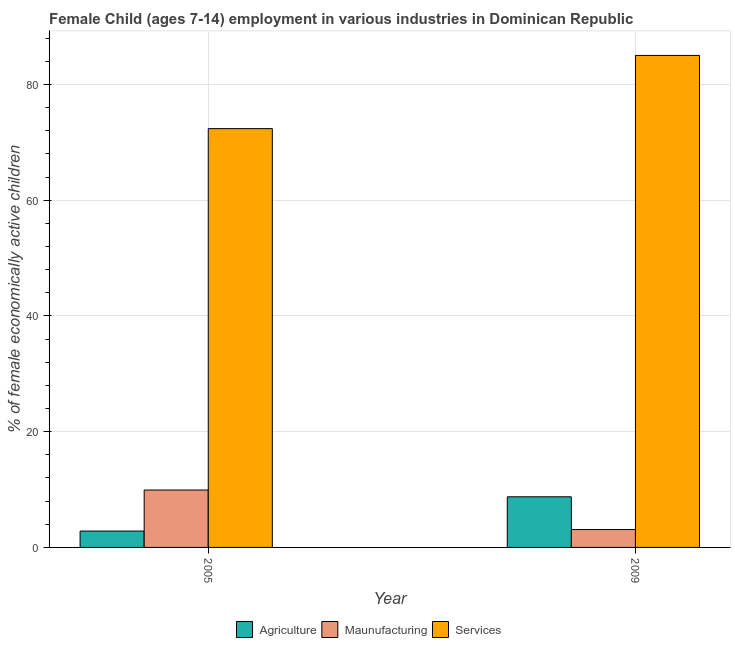How many groups of bars are there?
Your answer should be very brief. 2. Are the number of bars on each tick of the X-axis equal?
Give a very brief answer. Yes. How many bars are there on the 1st tick from the right?
Offer a terse response. 3. What is the percentage of economically active children in services in 2009?
Provide a succinct answer. 85.03. Across all years, what is the maximum percentage of economically active children in services?
Provide a short and direct response. 85.03. Across all years, what is the minimum percentage of economically active children in manufacturing?
Give a very brief answer. 3.09. In which year was the percentage of economically active children in services maximum?
Provide a short and direct response. 2009. What is the total percentage of economically active children in agriculture in the graph?
Provide a succinct answer. 11.58. What is the difference between the percentage of economically active children in services in 2005 and that in 2009?
Provide a short and direct response. -12.65. What is the difference between the percentage of economically active children in manufacturing in 2005 and the percentage of economically active children in agriculture in 2009?
Ensure brevity in your answer.  6.83. What is the average percentage of economically active children in services per year?
Provide a short and direct response. 78.7. In how many years, is the percentage of economically active children in services greater than 20 %?
Your answer should be very brief. 2. What is the ratio of the percentage of economically active children in agriculture in 2005 to that in 2009?
Your response must be concise. 0.32. Is the percentage of economically active children in manufacturing in 2005 less than that in 2009?
Keep it short and to the point. No. In how many years, is the percentage of economically active children in agriculture greater than the average percentage of economically active children in agriculture taken over all years?
Keep it short and to the point. 1. What does the 2nd bar from the left in 2009 represents?
Your answer should be compact. Maunufacturing. What does the 2nd bar from the right in 2009 represents?
Provide a succinct answer. Maunufacturing. Are all the bars in the graph horizontal?
Offer a terse response. No. How many years are there in the graph?
Offer a terse response. 2. Does the graph contain any zero values?
Your answer should be compact. No. Does the graph contain grids?
Offer a terse response. Yes. How many legend labels are there?
Make the answer very short. 3. What is the title of the graph?
Offer a very short reply. Female Child (ages 7-14) employment in various industries in Dominican Republic. Does "Ireland" appear as one of the legend labels in the graph?
Offer a terse response. No. What is the label or title of the X-axis?
Make the answer very short. Year. What is the label or title of the Y-axis?
Your answer should be compact. % of female economically active children. What is the % of female economically active children in Agriculture in 2005?
Give a very brief answer. 2.83. What is the % of female economically active children in Maunufacturing in 2005?
Provide a short and direct response. 9.92. What is the % of female economically active children of Services in 2005?
Keep it short and to the point. 72.38. What is the % of female economically active children in Agriculture in 2009?
Make the answer very short. 8.75. What is the % of female economically active children in Maunufacturing in 2009?
Provide a short and direct response. 3.09. What is the % of female economically active children of Services in 2009?
Provide a succinct answer. 85.03. Across all years, what is the maximum % of female economically active children in Agriculture?
Keep it short and to the point. 8.75. Across all years, what is the maximum % of female economically active children in Maunufacturing?
Your response must be concise. 9.92. Across all years, what is the maximum % of female economically active children in Services?
Your response must be concise. 85.03. Across all years, what is the minimum % of female economically active children in Agriculture?
Keep it short and to the point. 2.83. Across all years, what is the minimum % of female economically active children of Maunufacturing?
Offer a very short reply. 3.09. Across all years, what is the minimum % of female economically active children of Services?
Keep it short and to the point. 72.38. What is the total % of female economically active children of Agriculture in the graph?
Give a very brief answer. 11.58. What is the total % of female economically active children in Maunufacturing in the graph?
Your answer should be very brief. 13.01. What is the total % of female economically active children of Services in the graph?
Keep it short and to the point. 157.41. What is the difference between the % of female economically active children of Agriculture in 2005 and that in 2009?
Keep it short and to the point. -5.92. What is the difference between the % of female economically active children of Maunufacturing in 2005 and that in 2009?
Provide a succinct answer. 6.83. What is the difference between the % of female economically active children of Services in 2005 and that in 2009?
Ensure brevity in your answer.  -12.65. What is the difference between the % of female economically active children of Agriculture in 2005 and the % of female economically active children of Maunufacturing in 2009?
Make the answer very short. -0.26. What is the difference between the % of female economically active children in Agriculture in 2005 and the % of female economically active children in Services in 2009?
Your answer should be very brief. -82.2. What is the difference between the % of female economically active children in Maunufacturing in 2005 and the % of female economically active children in Services in 2009?
Provide a short and direct response. -75.11. What is the average % of female economically active children of Agriculture per year?
Your response must be concise. 5.79. What is the average % of female economically active children of Maunufacturing per year?
Ensure brevity in your answer.  6.5. What is the average % of female economically active children in Services per year?
Provide a short and direct response. 78.7. In the year 2005, what is the difference between the % of female economically active children in Agriculture and % of female economically active children in Maunufacturing?
Ensure brevity in your answer.  -7.09. In the year 2005, what is the difference between the % of female economically active children of Agriculture and % of female economically active children of Services?
Make the answer very short. -69.55. In the year 2005, what is the difference between the % of female economically active children of Maunufacturing and % of female economically active children of Services?
Keep it short and to the point. -62.46. In the year 2009, what is the difference between the % of female economically active children of Agriculture and % of female economically active children of Maunufacturing?
Your response must be concise. 5.66. In the year 2009, what is the difference between the % of female economically active children of Agriculture and % of female economically active children of Services?
Keep it short and to the point. -76.28. In the year 2009, what is the difference between the % of female economically active children in Maunufacturing and % of female economically active children in Services?
Provide a short and direct response. -81.94. What is the ratio of the % of female economically active children in Agriculture in 2005 to that in 2009?
Offer a very short reply. 0.32. What is the ratio of the % of female economically active children in Maunufacturing in 2005 to that in 2009?
Your answer should be compact. 3.21. What is the ratio of the % of female economically active children in Services in 2005 to that in 2009?
Make the answer very short. 0.85. What is the difference between the highest and the second highest % of female economically active children of Agriculture?
Your answer should be compact. 5.92. What is the difference between the highest and the second highest % of female economically active children of Maunufacturing?
Your response must be concise. 6.83. What is the difference between the highest and the second highest % of female economically active children in Services?
Ensure brevity in your answer.  12.65. What is the difference between the highest and the lowest % of female economically active children of Agriculture?
Provide a succinct answer. 5.92. What is the difference between the highest and the lowest % of female economically active children of Maunufacturing?
Offer a very short reply. 6.83. What is the difference between the highest and the lowest % of female economically active children in Services?
Your response must be concise. 12.65. 